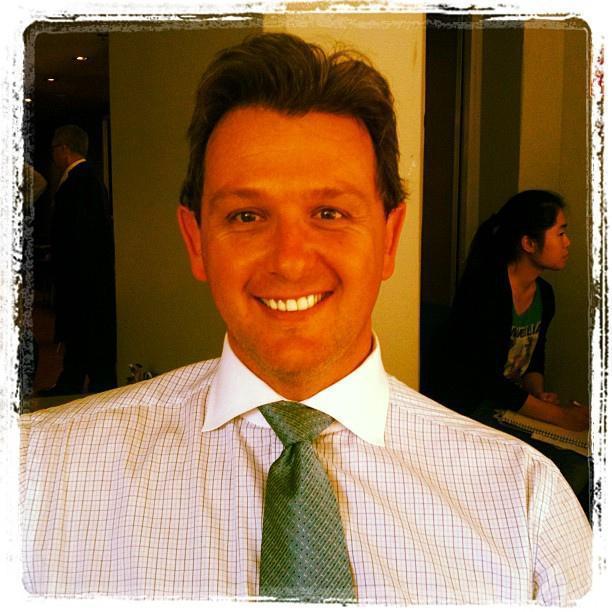How many people are there?
Give a very brief answer. 3. 